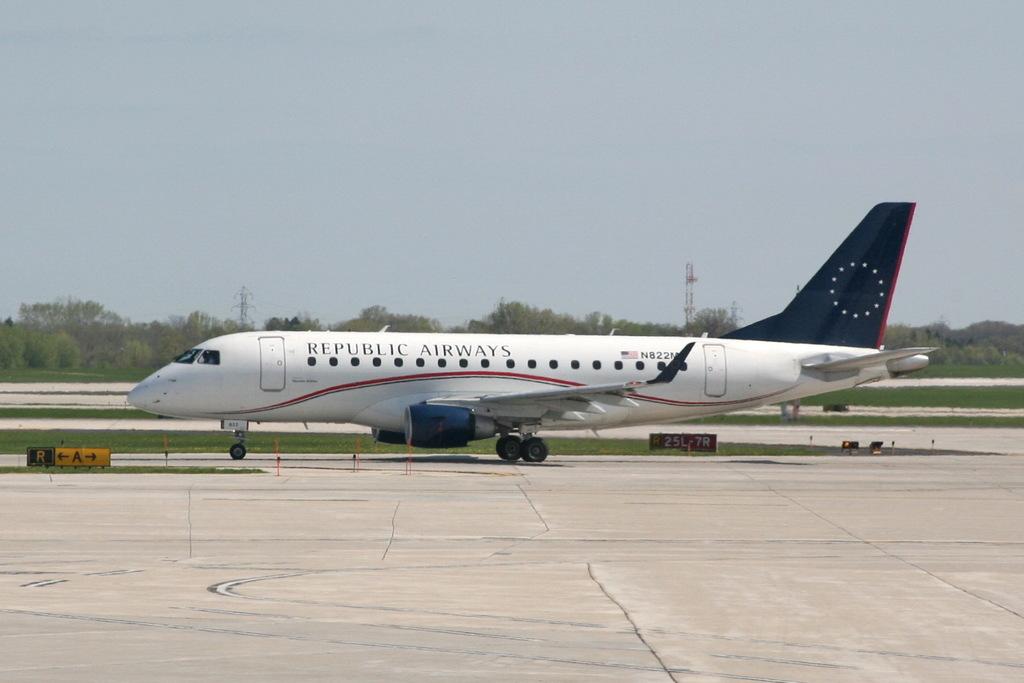What kind of plane is this?
Your response must be concise. Republic airways. 